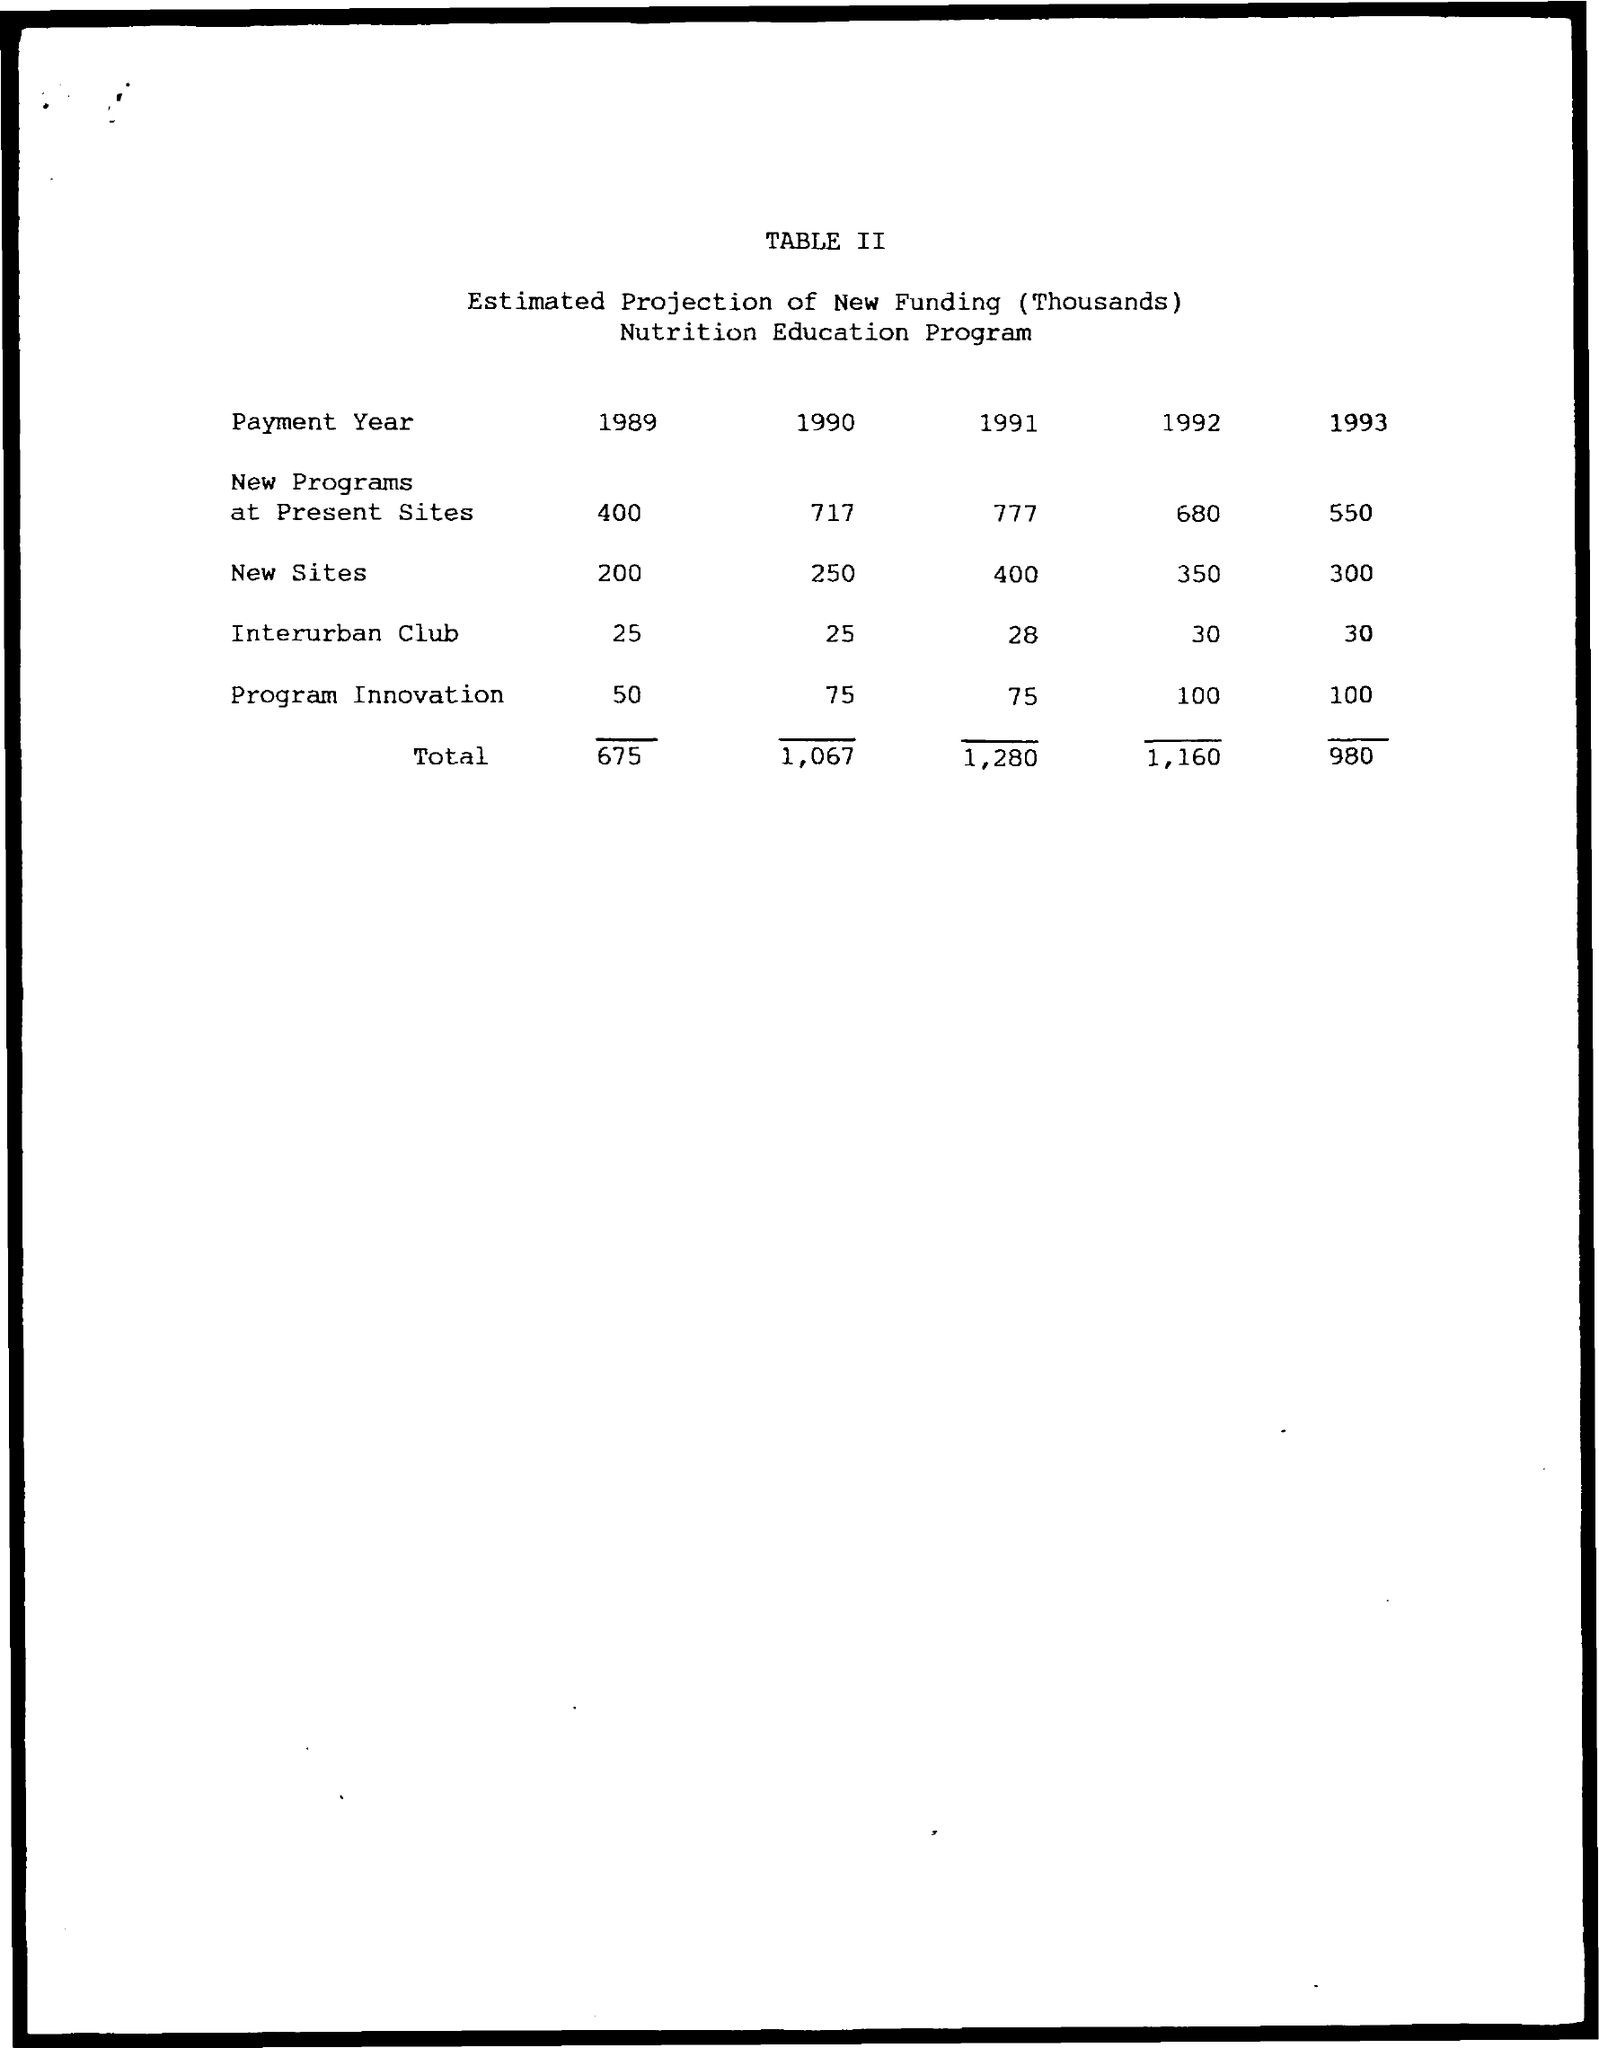What is the value of New Sites in the year 1989?
Ensure brevity in your answer.  200. What is the total amount of funding in the year 1993?
Your response must be concise. 980. What is the value of Interurban Club in the year 1991?
Your answer should be compact. 28. 